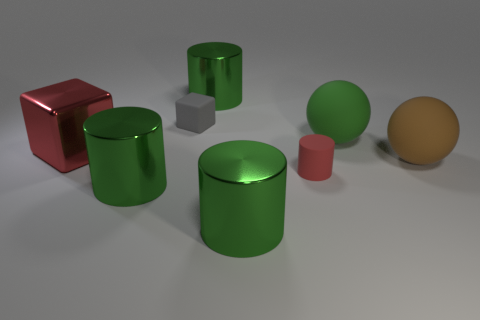Which object in the image reflects the most light and why? The object reflecting the most light in the image appears to be the red cube. Its shiny surface indicates that it is likely made of a reflective material such as glossy plastic or polished metal, causing it to reflect more light than the other objects which have a matte finish. 